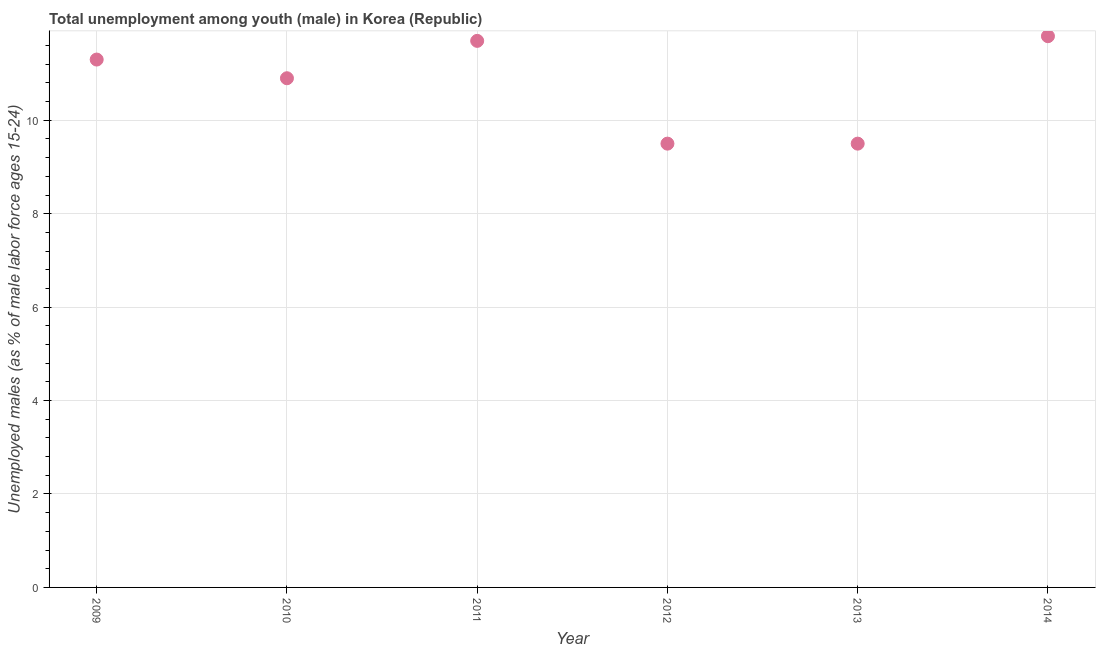What is the unemployed male youth population in 2010?
Make the answer very short. 10.9. Across all years, what is the maximum unemployed male youth population?
Your response must be concise. 11.8. In which year was the unemployed male youth population maximum?
Ensure brevity in your answer.  2014. In which year was the unemployed male youth population minimum?
Ensure brevity in your answer.  2012. What is the sum of the unemployed male youth population?
Keep it short and to the point. 64.7. What is the average unemployed male youth population per year?
Your response must be concise. 10.78. What is the median unemployed male youth population?
Offer a very short reply. 11.1. What is the ratio of the unemployed male youth population in 2009 to that in 2012?
Make the answer very short. 1.19. Is the unemployed male youth population in 2010 less than that in 2011?
Provide a short and direct response. Yes. What is the difference between the highest and the second highest unemployed male youth population?
Give a very brief answer. 0.1. Is the sum of the unemployed male youth population in 2010 and 2013 greater than the maximum unemployed male youth population across all years?
Your response must be concise. Yes. What is the difference between the highest and the lowest unemployed male youth population?
Ensure brevity in your answer.  2.3. In how many years, is the unemployed male youth population greater than the average unemployed male youth population taken over all years?
Offer a terse response. 4. Does the unemployed male youth population monotonically increase over the years?
Provide a succinct answer. No. How many dotlines are there?
Your answer should be compact. 1. Does the graph contain any zero values?
Your response must be concise. No. What is the title of the graph?
Give a very brief answer. Total unemployment among youth (male) in Korea (Republic). What is the label or title of the X-axis?
Offer a terse response. Year. What is the label or title of the Y-axis?
Provide a short and direct response. Unemployed males (as % of male labor force ages 15-24). What is the Unemployed males (as % of male labor force ages 15-24) in 2009?
Your answer should be compact. 11.3. What is the Unemployed males (as % of male labor force ages 15-24) in 2010?
Your response must be concise. 10.9. What is the Unemployed males (as % of male labor force ages 15-24) in 2011?
Offer a very short reply. 11.7. What is the Unemployed males (as % of male labor force ages 15-24) in 2013?
Offer a very short reply. 9.5. What is the Unemployed males (as % of male labor force ages 15-24) in 2014?
Keep it short and to the point. 11.8. What is the difference between the Unemployed males (as % of male labor force ages 15-24) in 2009 and 2013?
Provide a short and direct response. 1.8. What is the difference between the Unemployed males (as % of male labor force ages 15-24) in 2009 and 2014?
Ensure brevity in your answer.  -0.5. What is the difference between the Unemployed males (as % of male labor force ages 15-24) in 2010 and 2014?
Offer a terse response. -0.9. What is the difference between the Unemployed males (as % of male labor force ages 15-24) in 2011 and 2012?
Keep it short and to the point. 2.2. What is the difference between the Unemployed males (as % of male labor force ages 15-24) in 2012 and 2014?
Offer a terse response. -2.3. What is the difference between the Unemployed males (as % of male labor force ages 15-24) in 2013 and 2014?
Make the answer very short. -2.3. What is the ratio of the Unemployed males (as % of male labor force ages 15-24) in 2009 to that in 2010?
Your response must be concise. 1.04. What is the ratio of the Unemployed males (as % of male labor force ages 15-24) in 2009 to that in 2011?
Your response must be concise. 0.97. What is the ratio of the Unemployed males (as % of male labor force ages 15-24) in 2009 to that in 2012?
Your response must be concise. 1.19. What is the ratio of the Unemployed males (as % of male labor force ages 15-24) in 2009 to that in 2013?
Provide a succinct answer. 1.19. What is the ratio of the Unemployed males (as % of male labor force ages 15-24) in 2009 to that in 2014?
Ensure brevity in your answer.  0.96. What is the ratio of the Unemployed males (as % of male labor force ages 15-24) in 2010 to that in 2011?
Make the answer very short. 0.93. What is the ratio of the Unemployed males (as % of male labor force ages 15-24) in 2010 to that in 2012?
Ensure brevity in your answer.  1.15. What is the ratio of the Unemployed males (as % of male labor force ages 15-24) in 2010 to that in 2013?
Provide a short and direct response. 1.15. What is the ratio of the Unemployed males (as % of male labor force ages 15-24) in 2010 to that in 2014?
Offer a terse response. 0.92. What is the ratio of the Unemployed males (as % of male labor force ages 15-24) in 2011 to that in 2012?
Keep it short and to the point. 1.23. What is the ratio of the Unemployed males (as % of male labor force ages 15-24) in 2011 to that in 2013?
Offer a terse response. 1.23. What is the ratio of the Unemployed males (as % of male labor force ages 15-24) in 2012 to that in 2013?
Offer a very short reply. 1. What is the ratio of the Unemployed males (as % of male labor force ages 15-24) in 2012 to that in 2014?
Make the answer very short. 0.81. What is the ratio of the Unemployed males (as % of male labor force ages 15-24) in 2013 to that in 2014?
Keep it short and to the point. 0.81. 